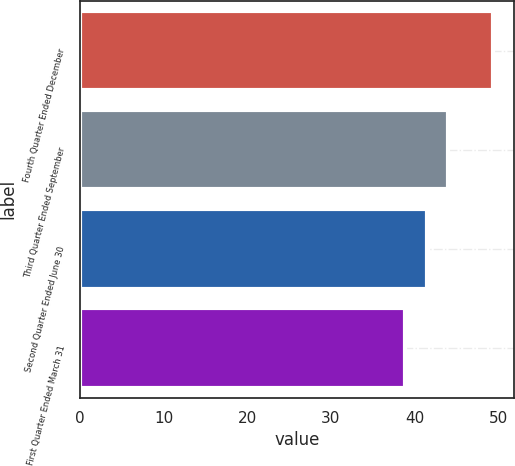Convert chart. <chart><loc_0><loc_0><loc_500><loc_500><bar_chart><fcel>Fourth Quarter Ended December<fcel>Third Quarter Ended September<fcel>Second Quarter Ended June 30<fcel>First Quarter Ended March 31<nl><fcel>49.42<fcel>44.04<fcel>41.45<fcel>38.84<nl></chart> 